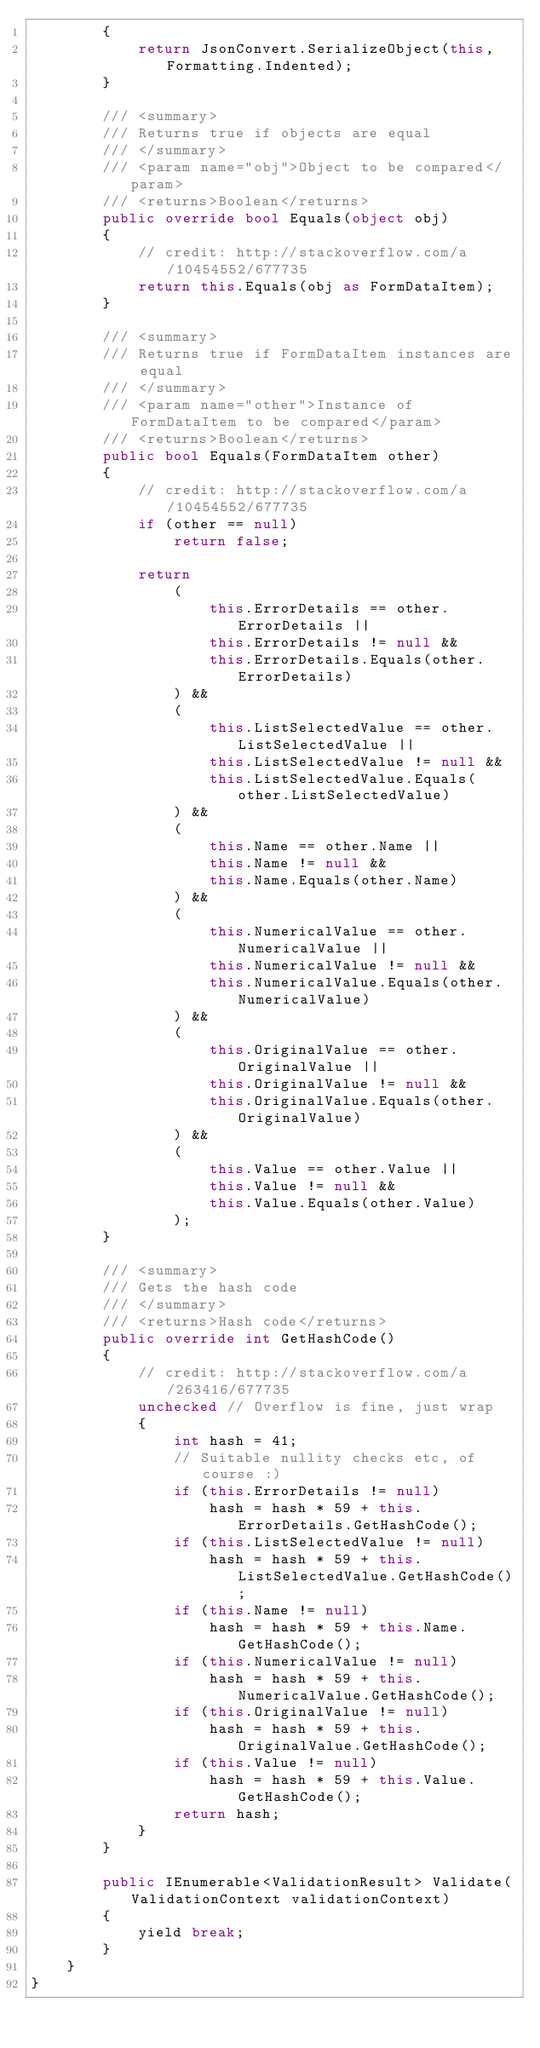Convert code to text. <code><loc_0><loc_0><loc_500><loc_500><_C#_>        {
            return JsonConvert.SerializeObject(this, Formatting.Indented);
        }

        /// <summary>
        /// Returns true if objects are equal
        /// </summary>
        /// <param name="obj">Object to be compared</param>
        /// <returns>Boolean</returns>
        public override bool Equals(object obj)
        {
            // credit: http://stackoverflow.com/a/10454552/677735
            return this.Equals(obj as FormDataItem);
        }

        /// <summary>
        /// Returns true if FormDataItem instances are equal
        /// </summary>
        /// <param name="other">Instance of FormDataItem to be compared</param>
        /// <returns>Boolean</returns>
        public bool Equals(FormDataItem other)
        {
            // credit: http://stackoverflow.com/a/10454552/677735
            if (other == null)
                return false;

            return 
                (
                    this.ErrorDetails == other.ErrorDetails ||
                    this.ErrorDetails != null &&
                    this.ErrorDetails.Equals(other.ErrorDetails)
                ) && 
                (
                    this.ListSelectedValue == other.ListSelectedValue ||
                    this.ListSelectedValue != null &&
                    this.ListSelectedValue.Equals(other.ListSelectedValue)
                ) && 
                (
                    this.Name == other.Name ||
                    this.Name != null &&
                    this.Name.Equals(other.Name)
                ) && 
                (
                    this.NumericalValue == other.NumericalValue ||
                    this.NumericalValue != null &&
                    this.NumericalValue.Equals(other.NumericalValue)
                ) && 
                (
                    this.OriginalValue == other.OriginalValue ||
                    this.OriginalValue != null &&
                    this.OriginalValue.Equals(other.OriginalValue)
                ) && 
                (
                    this.Value == other.Value ||
                    this.Value != null &&
                    this.Value.Equals(other.Value)
                );
        }

        /// <summary>
        /// Gets the hash code
        /// </summary>
        /// <returns>Hash code</returns>
        public override int GetHashCode()
        {
            // credit: http://stackoverflow.com/a/263416/677735
            unchecked // Overflow is fine, just wrap
            {
                int hash = 41;
                // Suitable nullity checks etc, of course :)
                if (this.ErrorDetails != null)
                    hash = hash * 59 + this.ErrorDetails.GetHashCode();
                if (this.ListSelectedValue != null)
                    hash = hash * 59 + this.ListSelectedValue.GetHashCode();
                if (this.Name != null)
                    hash = hash * 59 + this.Name.GetHashCode();
                if (this.NumericalValue != null)
                    hash = hash * 59 + this.NumericalValue.GetHashCode();
                if (this.OriginalValue != null)
                    hash = hash * 59 + this.OriginalValue.GetHashCode();
                if (this.Value != null)
                    hash = hash * 59 + this.Value.GetHashCode();
                return hash;
            }
        }

        public IEnumerable<ValidationResult> Validate(ValidationContext validationContext)
        { 
            yield break;
        }
    }
}
</code> 